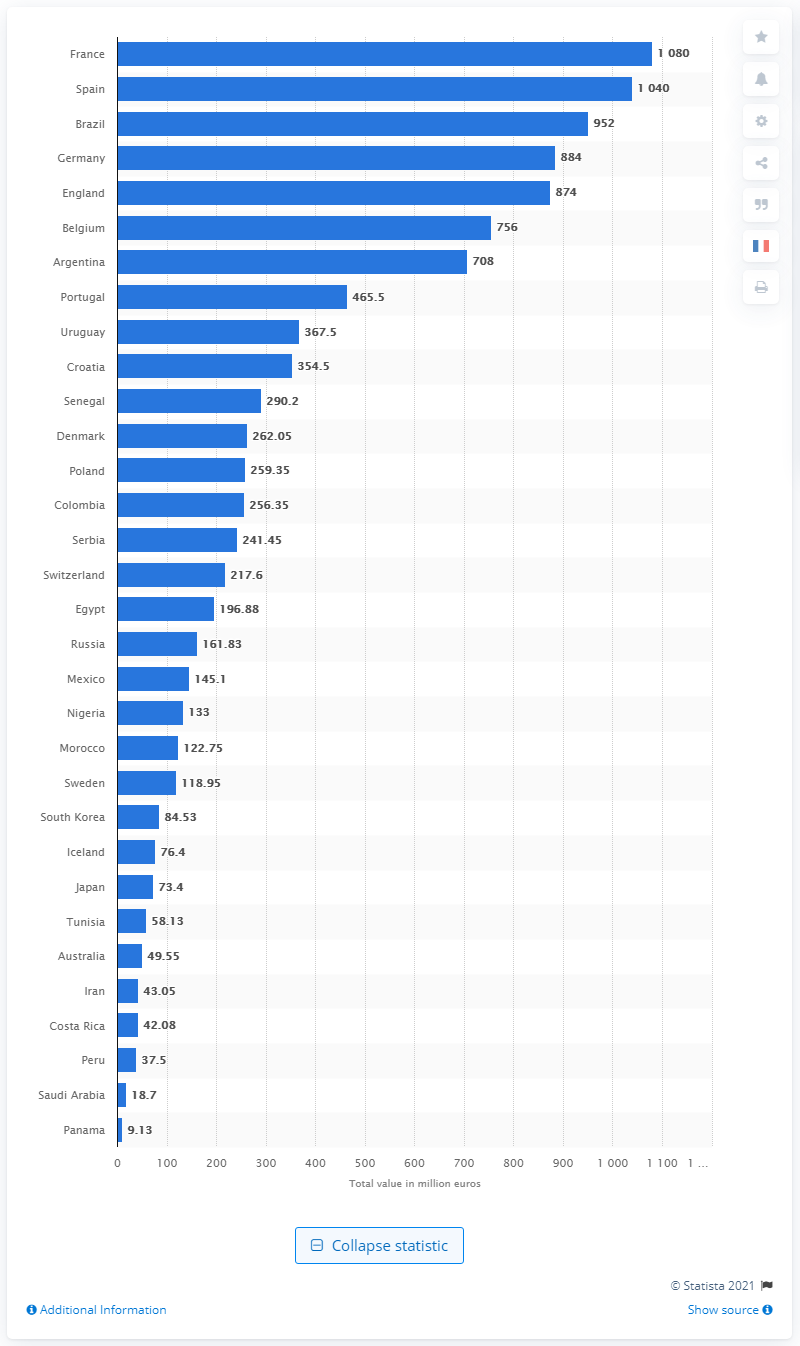Point out several critical features in this image. The market/transfer value of the France national squad was 1080. The 2018 FIFA World Cup was held in Russia. 